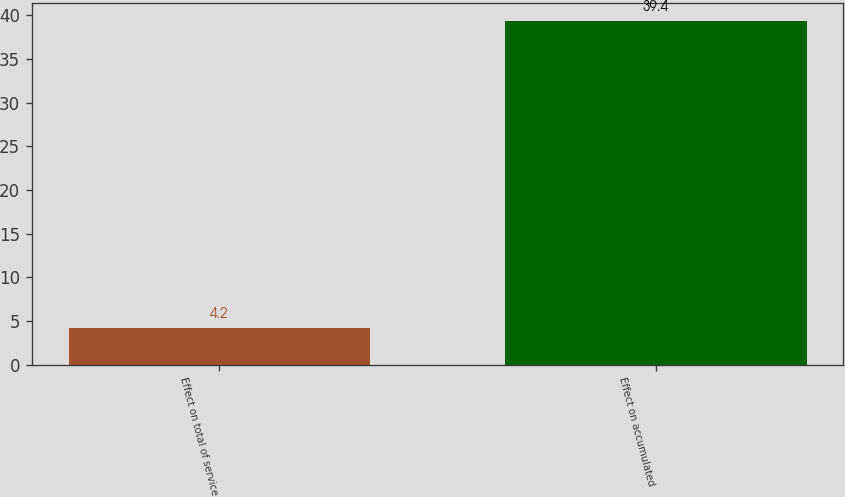<chart> <loc_0><loc_0><loc_500><loc_500><bar_chart><fcel>Effect on total of service<fcel>Effect on accumulated<nl><fcel>4.2<fcel>39.4<nl></chart> 